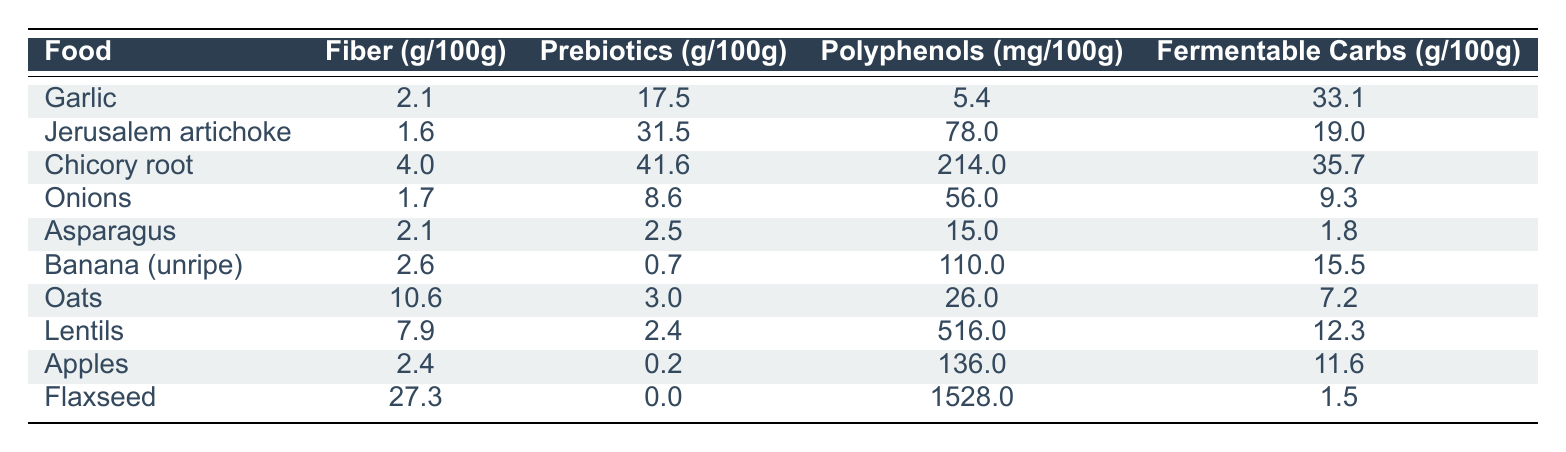What's the fiber content in flaxseed? Flaxseed has a fiber content of 27.3 grams per 100 grams, as indicated in the table.
Answer: 27.3 grams Which food has the highest polyphenol content? The food with the highest polyphenol content is flaxseed, with 1528.0 mg per 100 grams.
Answer: Flaxseed Is the prebiotic content in Jerusalem artichoke greater than that in onions? The prebiotic content in Jerusalem artichoke is 31.5 grams per 100 grams, while for onions it is only 8.6 grams. Yes, 31.5 exceeds 8.6.
Answer: Yes What is the average fermentable carbs content of chicory root, garlic, and asparagus? The fermentable carbs for chicory root is 35.7 grams, for garlic is 33.1 grams, and for asparagus is 1.8 grams. The total is 35.7 + 33.1 + 1.8 = 70.6 grams. The average is 70.6 / 3 = 23.53 grams.
Answer: 23.53 grams Does any food in the table have a prebiotic content of zero? Based on the table, flaxseed has a prebiotic content of 0.0 grams per 100 grams, confirming that at least one food has zero prebiotics.
Answer: Yes Which food contains the least amount of fiber? The food with the least amount of fiber is Jerusalem artichoke with 1.6 grams per 100 grams, compared to the others listed.
Answer: 1.6 grams How much more prebiotic content does chicory root have compared to oats? Chicory root has 41.6 grams of prebiotics, while oats have 3.0 grams. The difference is 41.6 - 3.0 = 38.6 grams.
Answer: 38.6 grams Which food has the lowest fiber and lowest fermentable carbs? Jerusalem artichoke has the lowest fiber at 1.6 grams and lowest fermentable carbs at 19.0 grams among the foods listed.
Answer: Jerusalem artichoke What is the total polyphenol content of apples, oats, and lentils combined? Apples have 136.0 mg, oats have 26.0 mg, and lentils have 516.0 mg. Adding these gives 136.0 + 26.0 + 516.0 = 678.0 mg.
Answer: 678.0 mg 